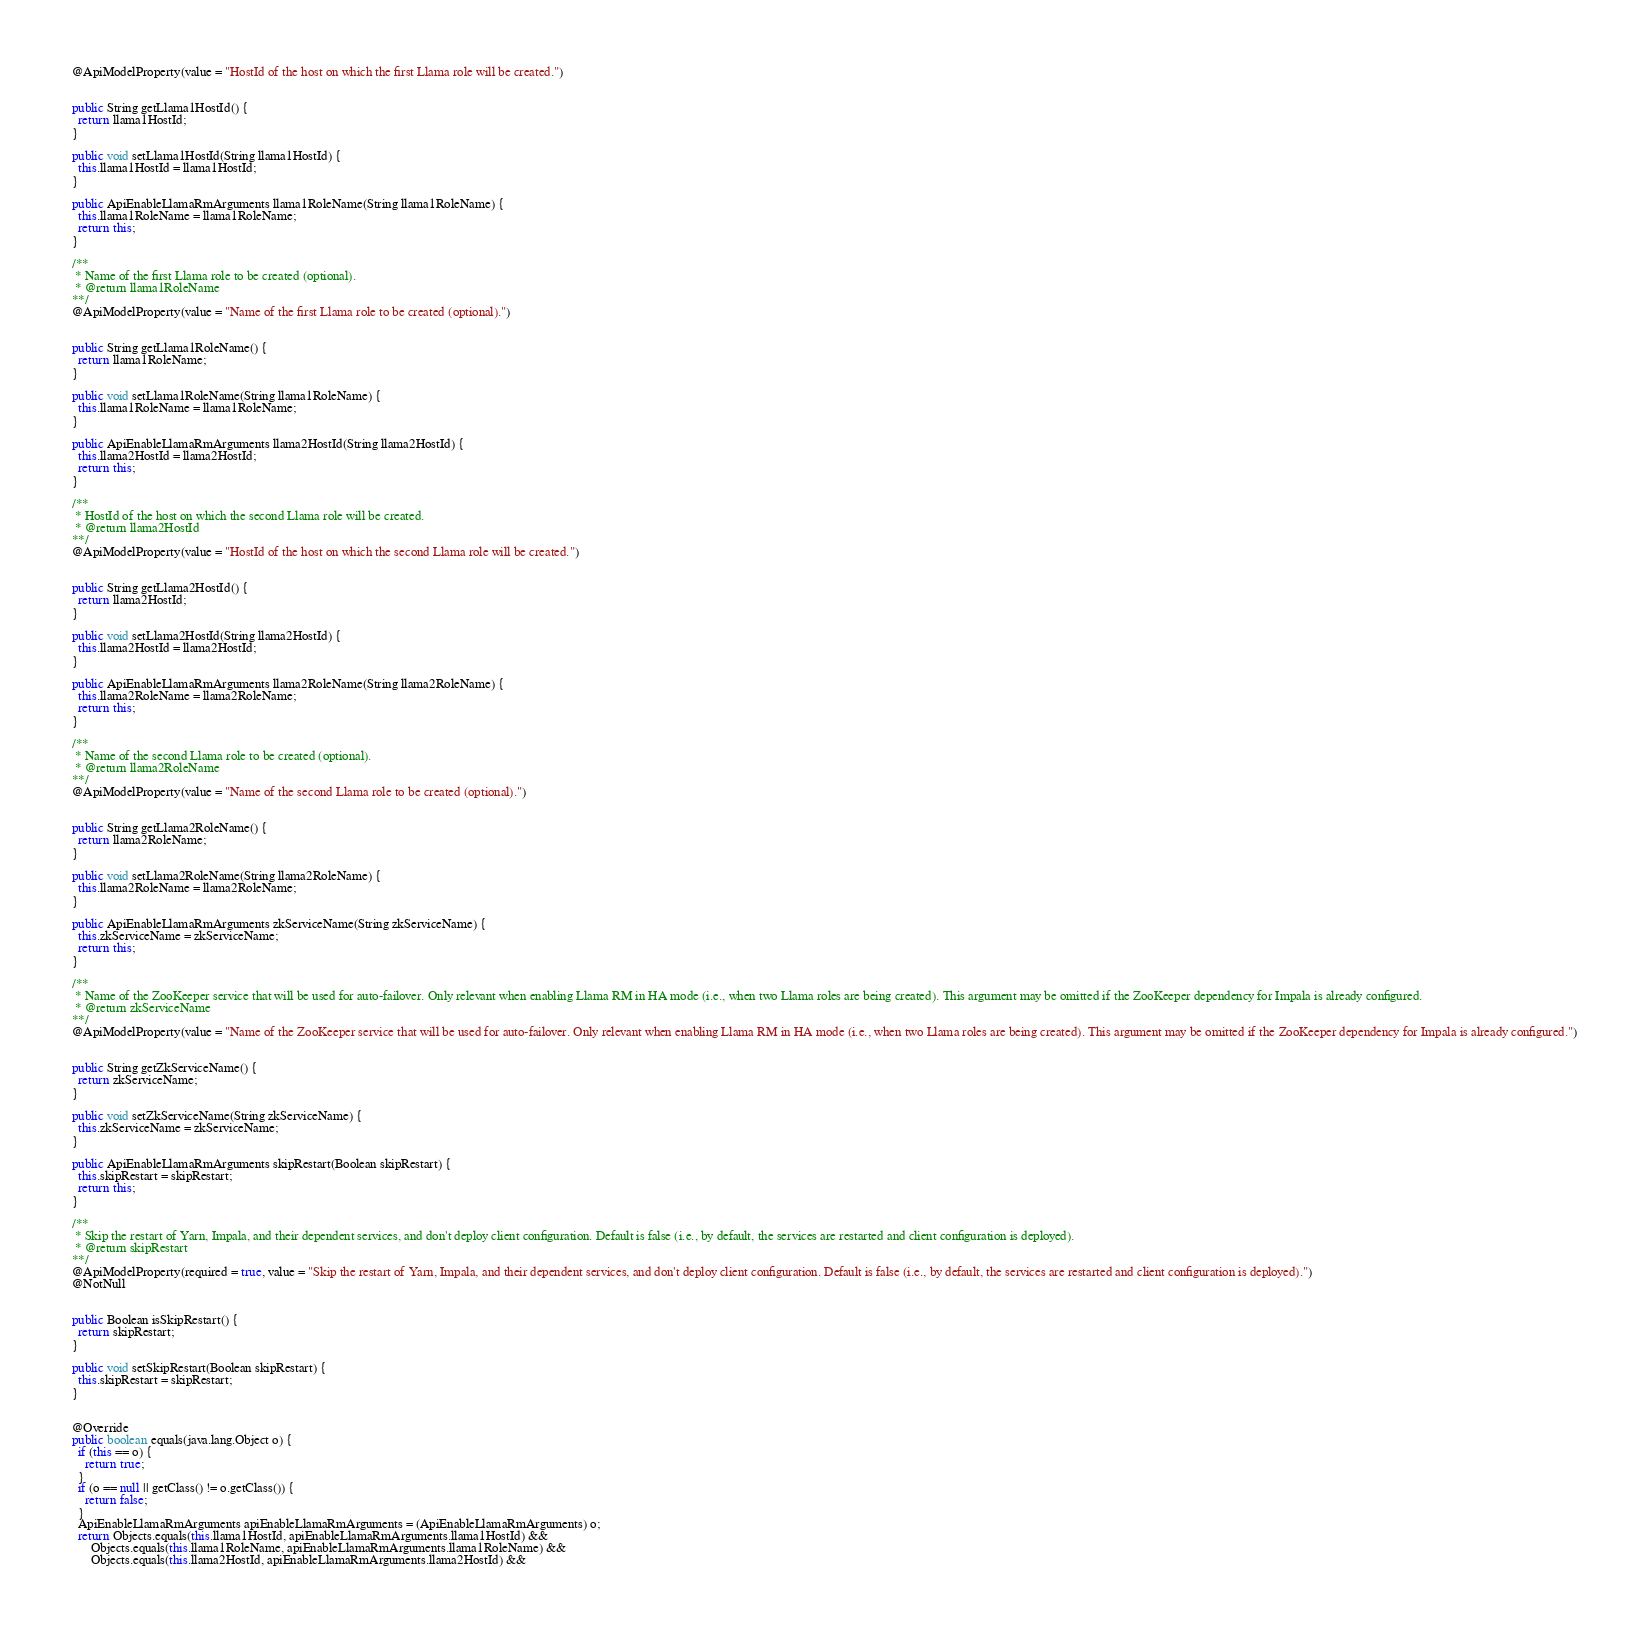<code> <loc_0><loc_0><loc_500><loc_500><_Java_>  @ApiModelProperty(value = "HostId of the host on which the first Llama role will be created.")


  public String getLlama1HostId() {
    return llama1HostId;
  }

  public void setLlama1HostId(String llama1HostId) {
    this.llama1HostId = llama1HostId;
  }

  public ApiEnableLlamaRmArguments llama1RoleName(String llama1RoleName) {
    this.llama1RoleName = llama1RoleName;
    return this;
  }

  /**
   * Name of the first Llama role to be created (optional).
   * @return llama1RoleName
  **/
  @ApiModelProperty(value = "Name of the first Llama role to be created (optional).")


  public String getLlama1RoleName() {
    return llama1RoleName;
  }

  public void setLlama1RoleName(String llama1RoleName) {
    this.llama1RoleName = llama1RoleName;
  }

  public ApiEnableLlamaRmArguments llama2HostId(String llama2HostId) {
    this.llama2HostId = llama2HostId;
    return this;
  }

  /**
   * HostId of the host on which the second Llama role will be created.
   * @return llama2HostId
  **/
  @ApiModelProperty(value = "HostId of the host on which the second Llama role will be created.")


  public String getLlama2HostId() {
    return llama2HostId;
  }

  public void setLlama2HostId(String llama2HostId) {
    this.llama2HostId = llama2HostId;
  }

  public ApiEnableLlamaRmArguments llama2RoleName(String llama2RoleName) {
    this.llama2RoleName = llama2RoleName;
    return this;
  }

  /**
   * Name of the second Llama role to be created (optional).
   * @return llama2RoleName
  **/
  @ApiModelProperty(value = "Name of the second Llama role to be created (optional).")


  public String getLlama2RoleName() {
    return llama2RoleName;
  }

  public void setLlama2RoleName(String llama2RoleName) {
    this.llama2RoleName = llama2RoleName;
  }

  public ApiEnableLlamaRmArguments zkServiceName(String zkServiceName) {
    this.zkServiceName = zkServiceName;
    return this;
  }

  /**
   * Name of the ZooKeeper service that will be used for auto-failover. Only relevant when enabling Llama RM in HA mode (i.e., when two Llama roles are being created). This argument may be omitted if the ZooKeeper dependency for Impala is already configured.
   * @return zkServiceName
  **/
  @ApiModelProperty(value = "Name of the ZooKeeper service that will be used for auto-failover. Only relevant when enabling Llama RM in HA mode (i.e., when two Llama roles are being created). This argument may be omitted if the ZooKeeper dependency for Impala is already configured.")


  public String getZkServiceName() {
    return zkServiceName;
  }

  public void setZkServiceName(String zkServiceName) {
    this.zkServiceName = zkServiceName;
  }

  public ApiEnableLlamaRmArguments skipRestart(Boolean skipRestart) {
    this.skipRestart = skipRestart;
    return this;
  }

  /**
   * Skip the restart of Yarn, Impala, and their dependent services, and don't deploy client configuration. Default is false (i.e., by default, the services are restarted and client configuration is deployed).
   * @return skipRestart
  **/
  @ApiModelProperty(required = true, value = "Skip the restart of Yarn, Impala, and their dependent services, and don't deploy client configuration. Default is false (i.e., by default, the services are restarted and client configuration is deployed).")
  @NotNull


  public Boolean isSkipRestart() {
    return skipRestart;
  }

  public void setSkipRestart(Boolean skipRestart) {
    this.skipRestart = skipRestart;
  }


  @Override
  public boolean equals(java.lang.Object o) {
    if (this == o) {
      return true;
    }
    if (o == null || getClass() != o.getClass()) {
      return false;
    }
    ApiEnableLlamaRmArguments apiEnableLlamaRmArguments = (ApiEnableLlamaRmArguments) o;
    return Objects.equals(this.llama1HostId, apiEnableLlamaRmArguments.llama1HostId) &&
        Objects.equals(this.llama1RoleName, apiEnableLlamaRmArguments.llama1RoleName) &&
        Objects.equals(this.llama2HostId, apiEnableLlamaRmArguments.llama2HostId) &&</code> 